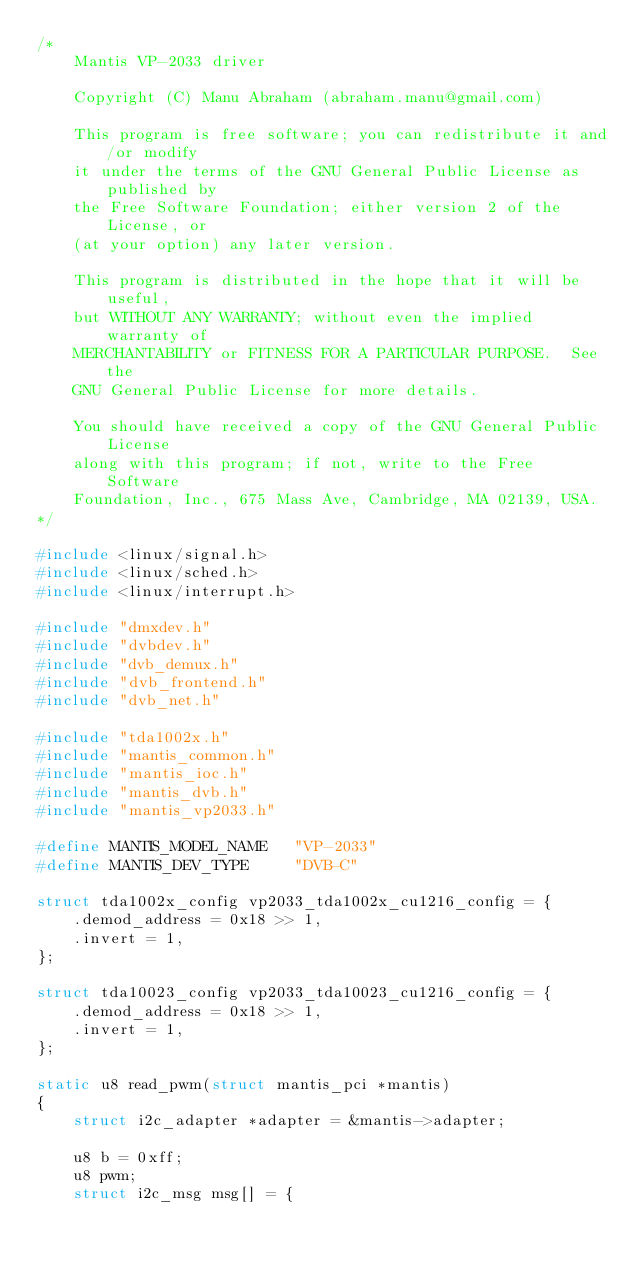Convert code to text. <code><loc_0><loc_0><loc_500><loc_500><_C_>/*
	Mantis VP-2033 driver

	Copyright (C) Manu Abraham (abraham.manu@gmail.com)

	This program is free software; you can redistribute it and/or modify
	it under the terms of the GNU General Public License as published by
	the Free Software Foundation; either version 2 of the License, or
	(at your option) any later version.

	This program is distributed in the hope that it will be useful,
	but WITHOUT ANY WARRANTY; without even the implied warranty of
	MERCHANTABILITY or FITNESS FOR A PARTICULAR PURPOSE.  See the
	GNU General Public License for more details.

	You should have received a copy of the GNU General Public License
	along with this program; if not, write to the Free Software
	Foundation, Inc., 675 Mass Ave, Cambridge, MA 02139, USA.
*/

#include <linux/signal.h>
#include <linux/sched.h>
#include <linux/interrupt.h>

#include "dmxdev.h"
#include "dvbdev.h"
#include "dvb_demux.h"
#include "dvb_frontend.h"
#include "dvb_net.h"

#include "tda1002x.h"
#include "mantis_common.h"
#include "mantis_ioc.h"
#include "mantis_dvb.h"
#include "mantis_vp2033.h"

#define MANTIS_MODEL_NAME	"VP-2033"
#define MANTIS_DEV_TYPE		"DVB-C"

struct tda1002x_config vp2033_tda1002x_cu1216_config = {
	.demod_address = 0x18 >> 1,
	.invert = 1,
};

struct tda10023_config vp2033_tda10023_cu1216_config = {
	.demod_address = 0x18 >> 1,
	.invert = 1,
};

static u8 read_pwm(struct mantis_pci *mantis)
{
	struct i2c_adapter *adapter = &mantis->adapter;

	u8 b = 0xff;
	u8 pwm;
	struct i2c_msg msg[] = {</code> 